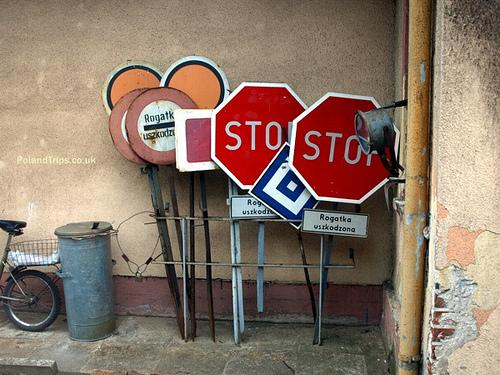Question: what has a cart attached to it?
Choices:
A. A motorcycle.
B. A tractor.
C. A scooter.
D. A bike.
Answer with the letter. Answer: D Question: what color are the signs?
Choices:
A. Yellow.
B. Brown.
C. Blue.
D. Red and orange.
Answer with the letter. Answer: D Question: where are the signs?
Choices:
A. On poles.
B. On gates.
C. On buildings.
D. Against a wall.
Answer with the letter. Answer: D Question: what is the wall made of?
Choices:
A. Brick.
B. Boards.
C. Concrete.
D. Stone.
Answer with the letter. Answer: D Question: why are there signs here?
Choices:
A. They are being stored.
B. To advertise.
C. To keep people out.
D. To keep them out of the way.
Answer with the letter. Answer: A Question: what does one of the sign say?
Choices:
A. Stop.
B. Yield.
C. Slow down.
D. Caution.
Answer with the letter. Answer: A 